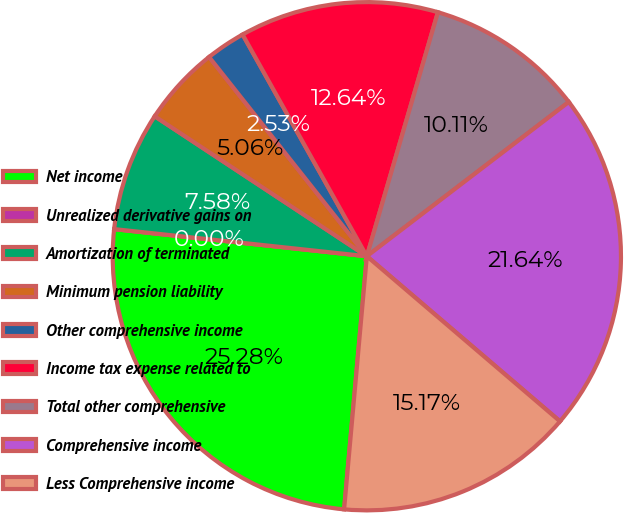Convert chart. <chart><loc_0><loc_0><loc_500><loc_500><pie_chart><fcel>Net income<fcel>Unrealized derivative gains on<fcel>Amortization of terminated<fcel>Minimum pension liability<fcel>Other comprehensive income<fcel>Income tax expense related to<fcel>Total other comprehensive<fcel>Comprehensive income<fcel>Less Comprehensive income<nl><fcel>25.28%<fcel>0.0%<fcel>7.58%<fcel>5.06%<fcel>2.53%<fcel>12.64%<fcel>10.11%<fcel>21.64%<fcel>15.17%<nl></chart> 